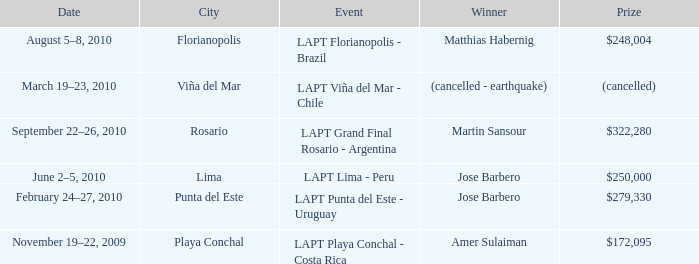What occasion is in florianopolis? LAPT Florianopolis - Brazil. 